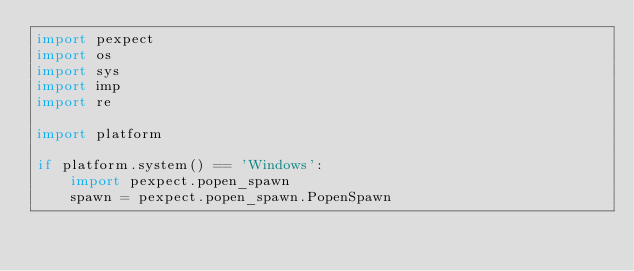<code> <loc_0><loc_0><loc_500><loc_500><_Python_>import pexpect
import os
import sys
import imp
import re

import platform

if platform.system() == 'Windows':
    import pexpect.popen_spawn
    spawn = pexpect.popen_spawn.PopenSpawn</code> 